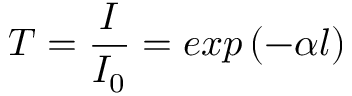Convert formula to latex. <formula><loc_0><loc_0><loc_500><loc_500>T = \frac { I } { I _ { 0 } } = e x p \left ( - \alpha l \right )</formula> 